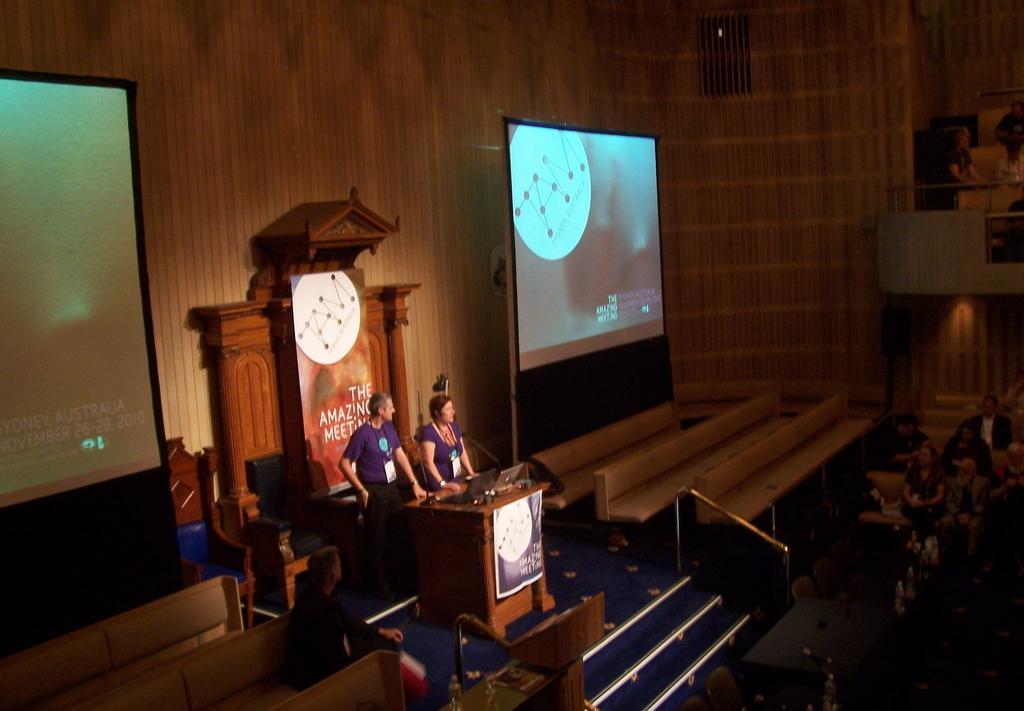Describe this image in one or two sentences. In this image we can see a few people, among them two people are standing in front of the podium, on the podium, we can see, mics, laptops and other objects, there are two projectors with some text and images, also we can see the benches and posters with text and images. 